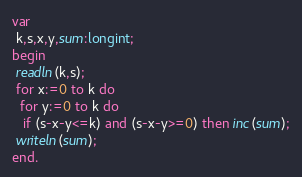<code> <loc_0><loc_0><loc_500><loc_500><_Pascal_>var
 k,s,x,y,sum:longint;
begin
 readln(k,s);
 for x:=0 to k do
  for y:=0 to k do
   if (s-x-y<=k) and (s-x-y>=0) then inc(sum);
 writeln(sum);
end.</code> 